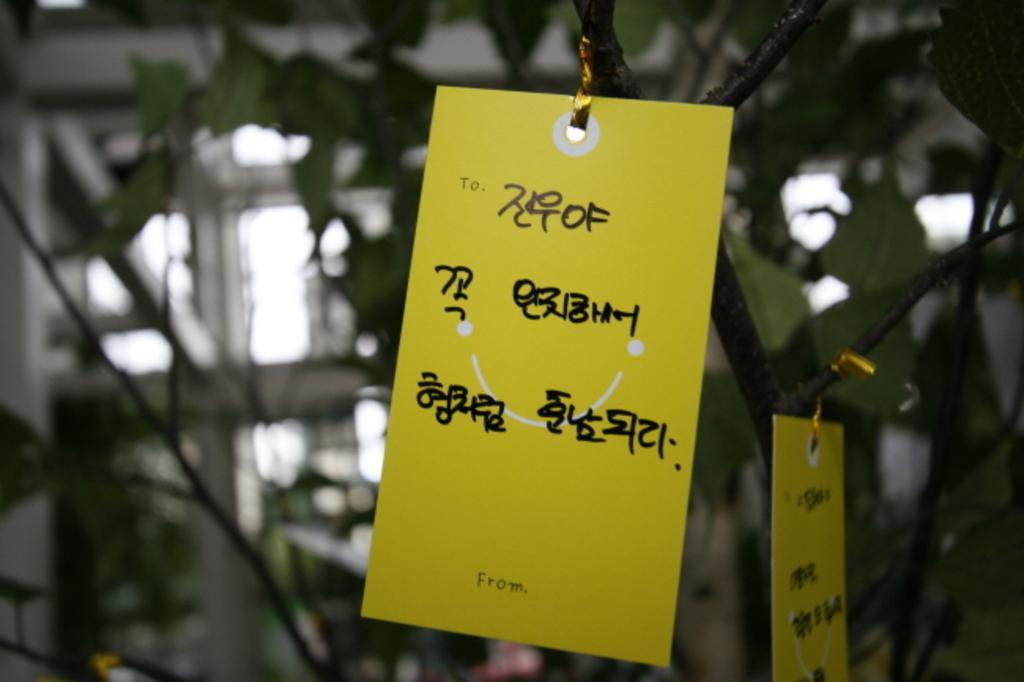Can you describe this image briefly? In this image, we can see a yellow color paper, in the background there is a tree. 